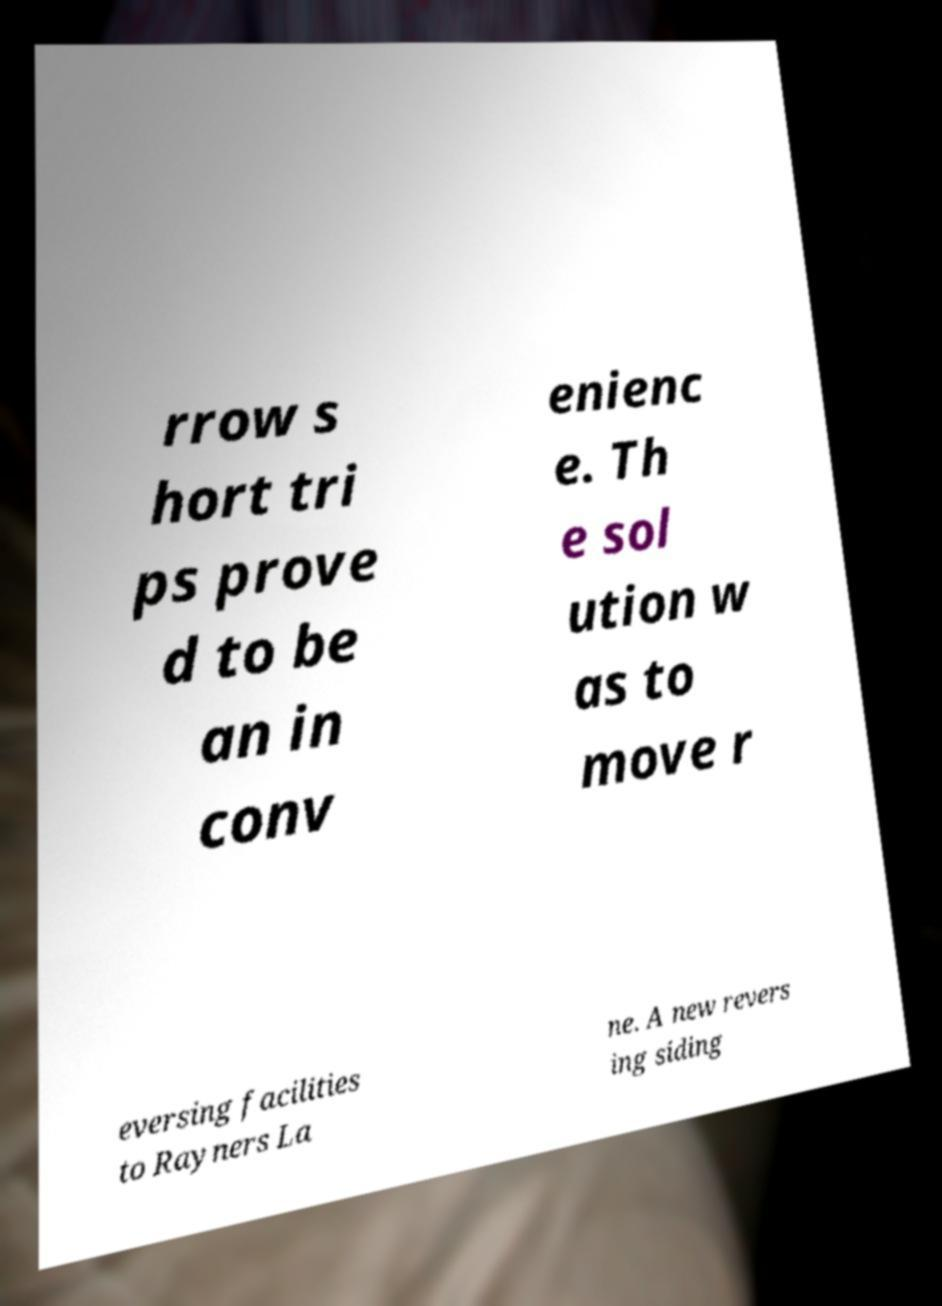I need the written content from this picture converted into text. Can you do that? rrow s hort tri ps prove d to be an in conv enienc e. Th e sol ution w as to move r eversing facilities to Rayners La ne. A new revers ing siding 